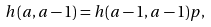<formula> <loc_0><loc_0><loc_500><loc_500>h ( a , a - 1 ) = h ( a - 1 , a - 1 ) p ,</formula> 